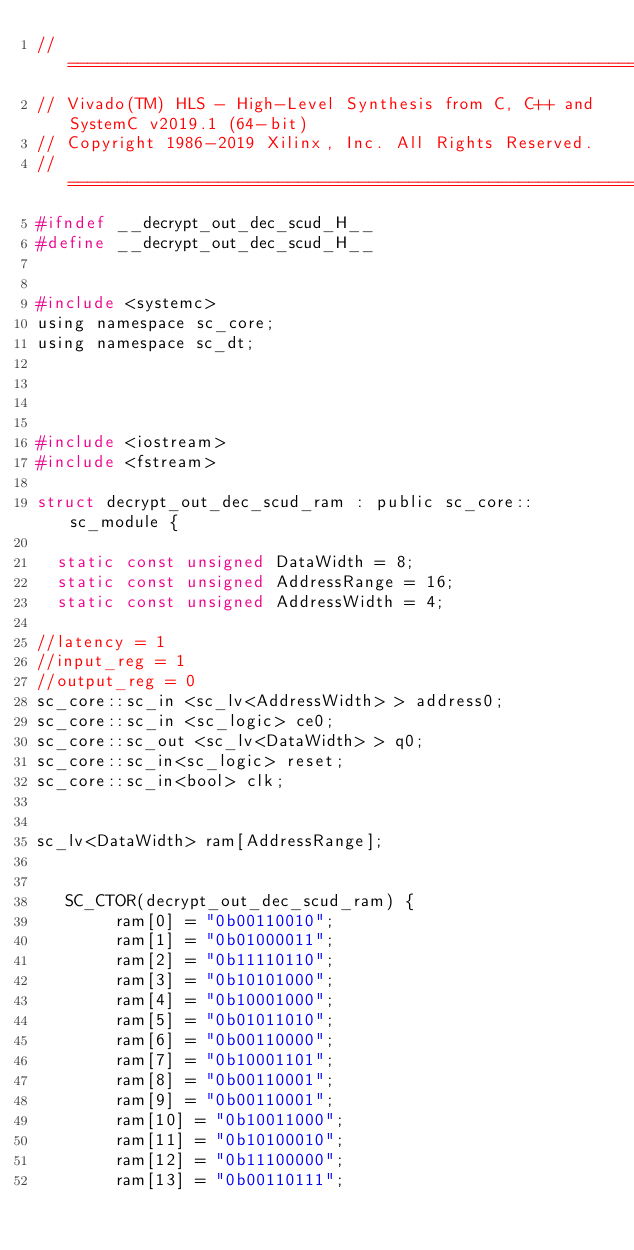<code> <loc_0><loc_0><loc_500><loc_500><_C_>// ==============================================================
// Vivado(TM) HLS - High-Level Synthesis from C, C++ and SystemC v2019.1 (64-bit)
// Copyright 1986-2019 Xilinx, Inc. All Rights Reserved.
// ==============================================================
#ifndef __decrypt_out_dec_scud_H__
#define __decrypt_out_dec_scud_H__


#include <systemc>
using namespace sc_core;
using namespace sc_dt;




#include <iostream>
#include <fstream>

struct decrypt_out_dec_scud_ram : public sc_core::sc_module {

  static const unsigned DataWidth = 8;
  static const unsigned AddressRange = 16;
  static const unsigned AddressWidth = 4;

//latency = 1
//input_reg = 1
//output_reg = 0
sc_core::sc_in <sc_lv<AddressWidth> > address0;
sc_core::sc_in <sc_logic> ce0;
sc_core::sc_out <sc_lv<DataWidth> > q0;
sc_core::sc_in<sc_logic> reset;
sc_core::sc_in<bool> clk;


sc_lv<DataWidth> ram[AddressRange];


   SC_CTOR(decrypt_out_dec_scud_ram) {
        ram[0] = "0b00110010";
        ram[1] = "0b01000011";
        ram[2] = "0b11110110";
        ram[3] = "0b10101000";
        ram[4] = "0b10001000";
        ram[5] = "0b01011010";
        ram[6] = "0b00110000";
        ram[7] = "0b10001101";
        ram[8] = "0b00110001";
        ram[9] = "0b00110001";
        ram[10] = "0b10011000";
        ram[11] = "0b10100010";
        ram[12] = "0b11100000";
        ram[13] = "0b00110111";</code> 